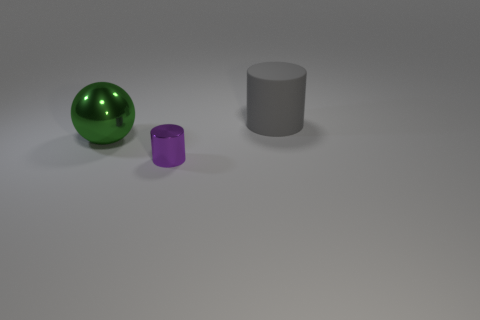Add 3 shiny objects. How many objects exist? 6 Subtract all balls. How many objects are left? 2 Add 1 small red metallic balls. How many small red metallic balls exist? 1 Subtract 0 blue balls. How many objects are left? 3 Subtract all spheres. Subtract all matte objects. How many objects are left? 1 Add 2 tiny purple cylinders. How many tiny purple cylinders are left? 3 